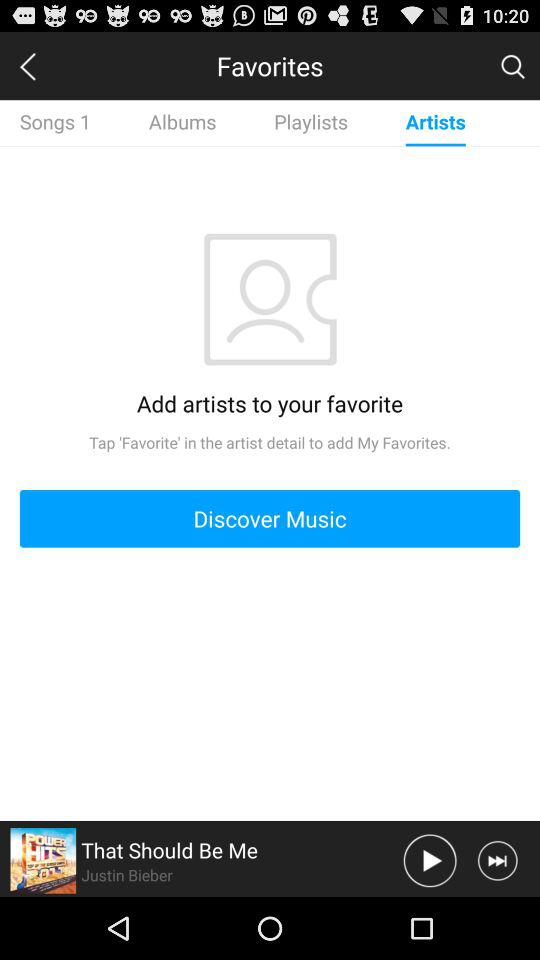Which tab is selected? The selected tab is "Artists". 